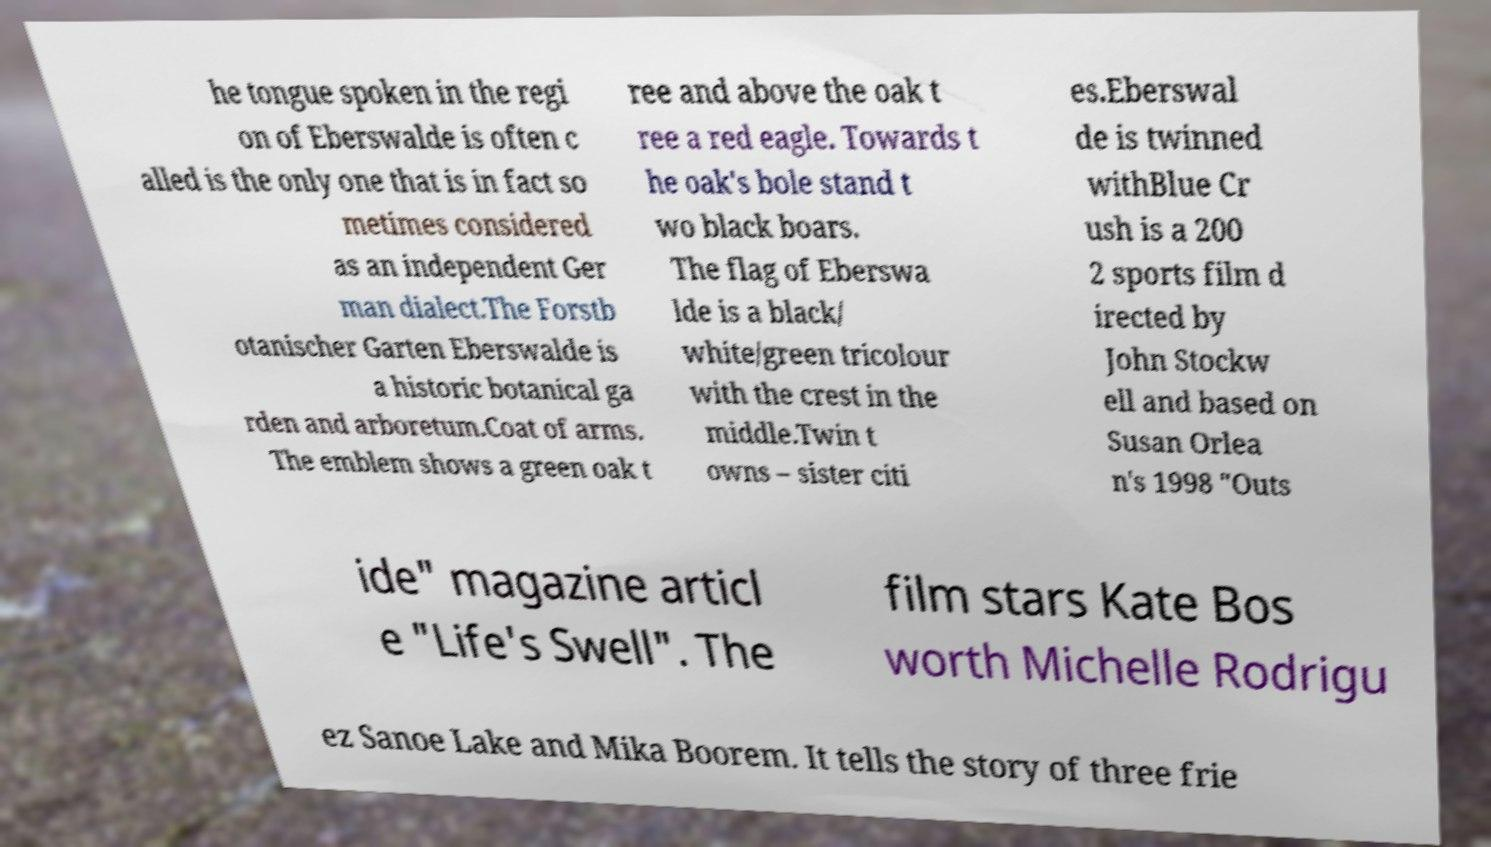For documentation purposes, I need the text within this image transcribed. Could you provide that? he tongue spoken in the regi on of Eberswalde is often c alled is the only one that is in fact so metimes considered as an independent Ger man dialect.The Forstb otanischer Garten Eberswalde is a historic botanical ga rden and arboretum.Coat of arms. The emblem shows a green oak t ree and above the oak t ree a red eagle. Towards t he oak's bole stand t wo black boars. The flag of Eberswa lde is a black/ white/green tricolour with the crest in the middle.Twin t owns – sister citi es.Eberswal de is twinned withBlue Cr ush is a 200 2 sports film d irected by John Stockw ell and based on Susan Orlea n's 1998 "Outs ide" magazine articl e "Life's Swell". The film stars Kate Bos worth Michelle Rodrigu ez Sanoe Lake and Mika Boorem. It tells the story of three frie 